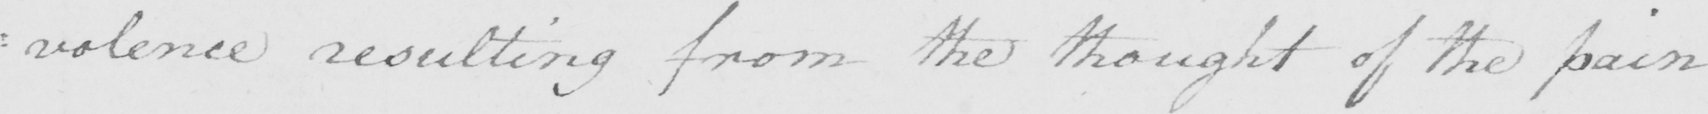What does this handwritten line say? : volence resulting from the thought of the pain 